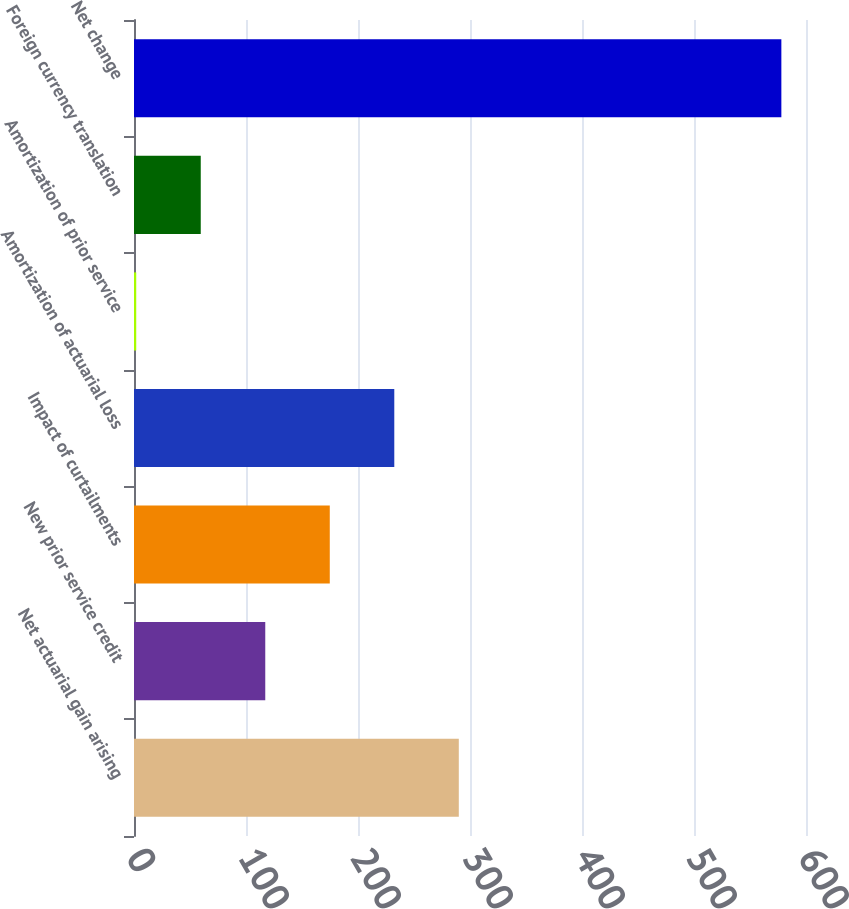Convert chart to OTSL. <chart><loc_0><loc_0><loc_500><loc_500><bar_chart><fcel>Net actuarial gain arising<fcel>New prior service credit<fcel>Impact of curtailments<fcel>Amortization of actuarial loss<fcel>Amortization of prior service<fcel>Foreign currency translation<fcel>Net change<nl><fcel>290<fcel>117.2<fcel>174.8<fcel>232.4<fcel>2<fcel>59.6<fcel>578<nl></chart> 